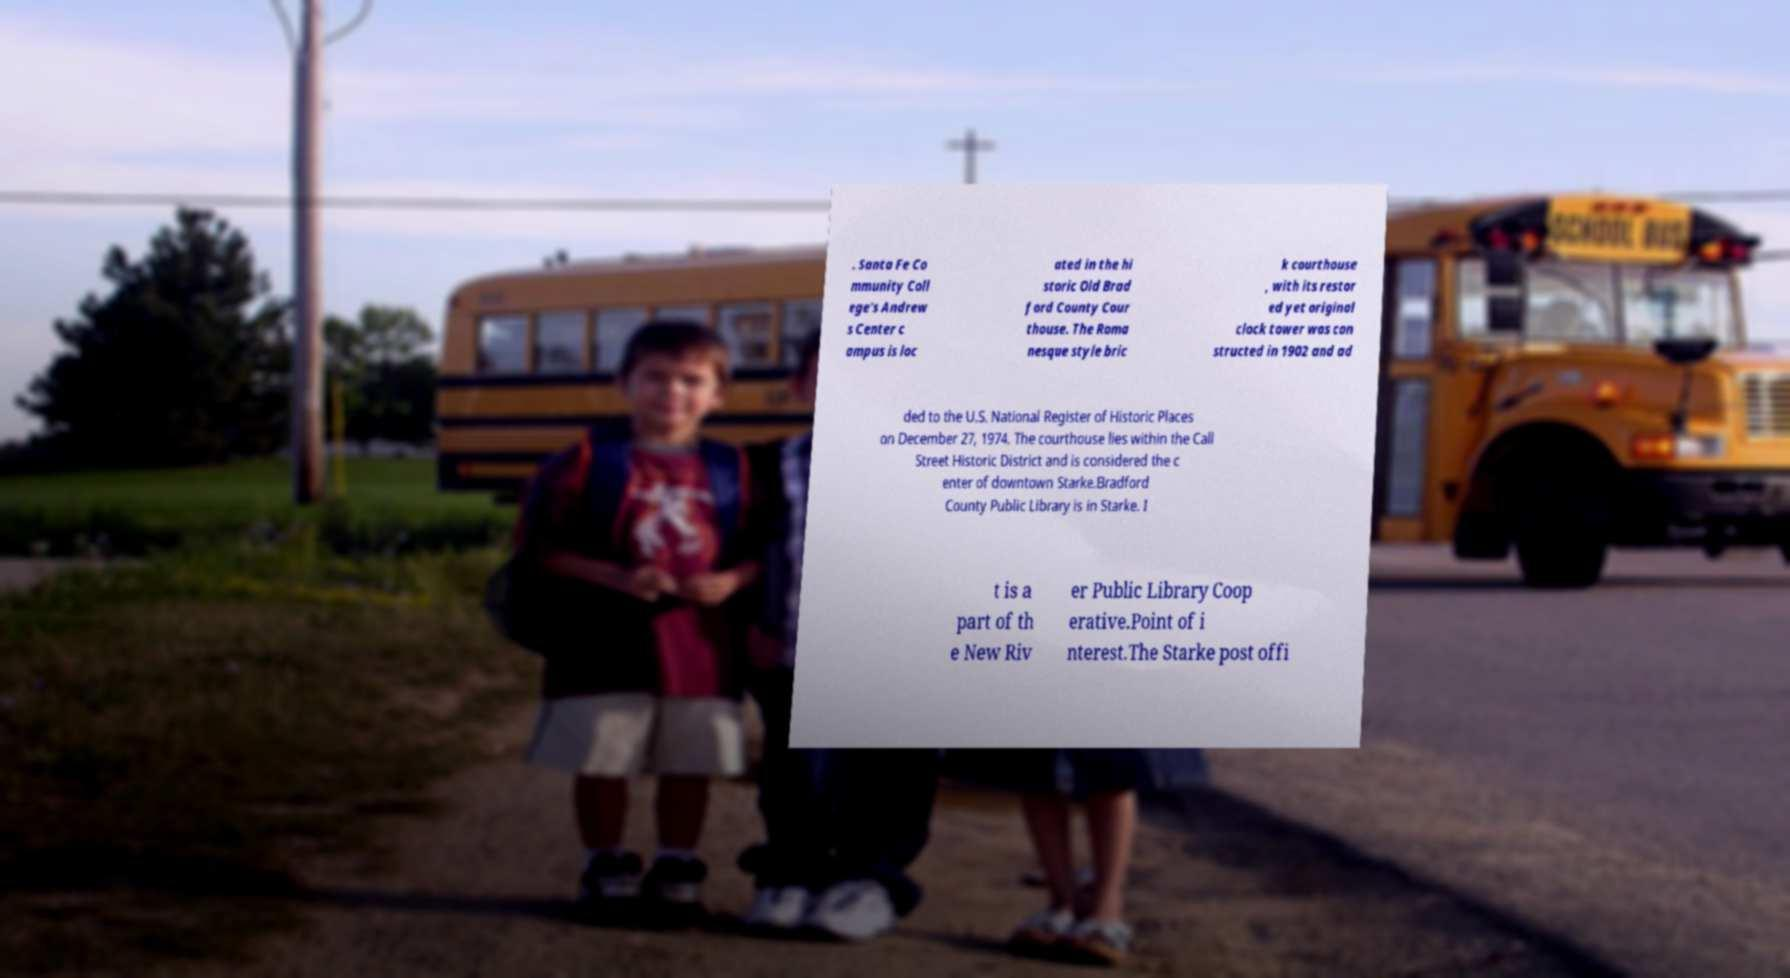Could you extract and type out the text from this image? . Santa Fe Co mmunity Coll ege's Andrew s Center c ampus is loc ated in the hi storic Old Brad ford County Cour thouse. The Roma nesque style bric k courthouse , with its restor ed yet original clock tower was con structed in 1902 and ad ded to the U.S. National Register of Historic Places on December 27, 1974. The courthouse lies within the Call Street Historic District and is considered the c enter of downtown Starke.Bradford County Public Library is in Starke. I t is a part of th e New Riv er Public Library Coop erative.Point of i nterest.The Starke post offi 